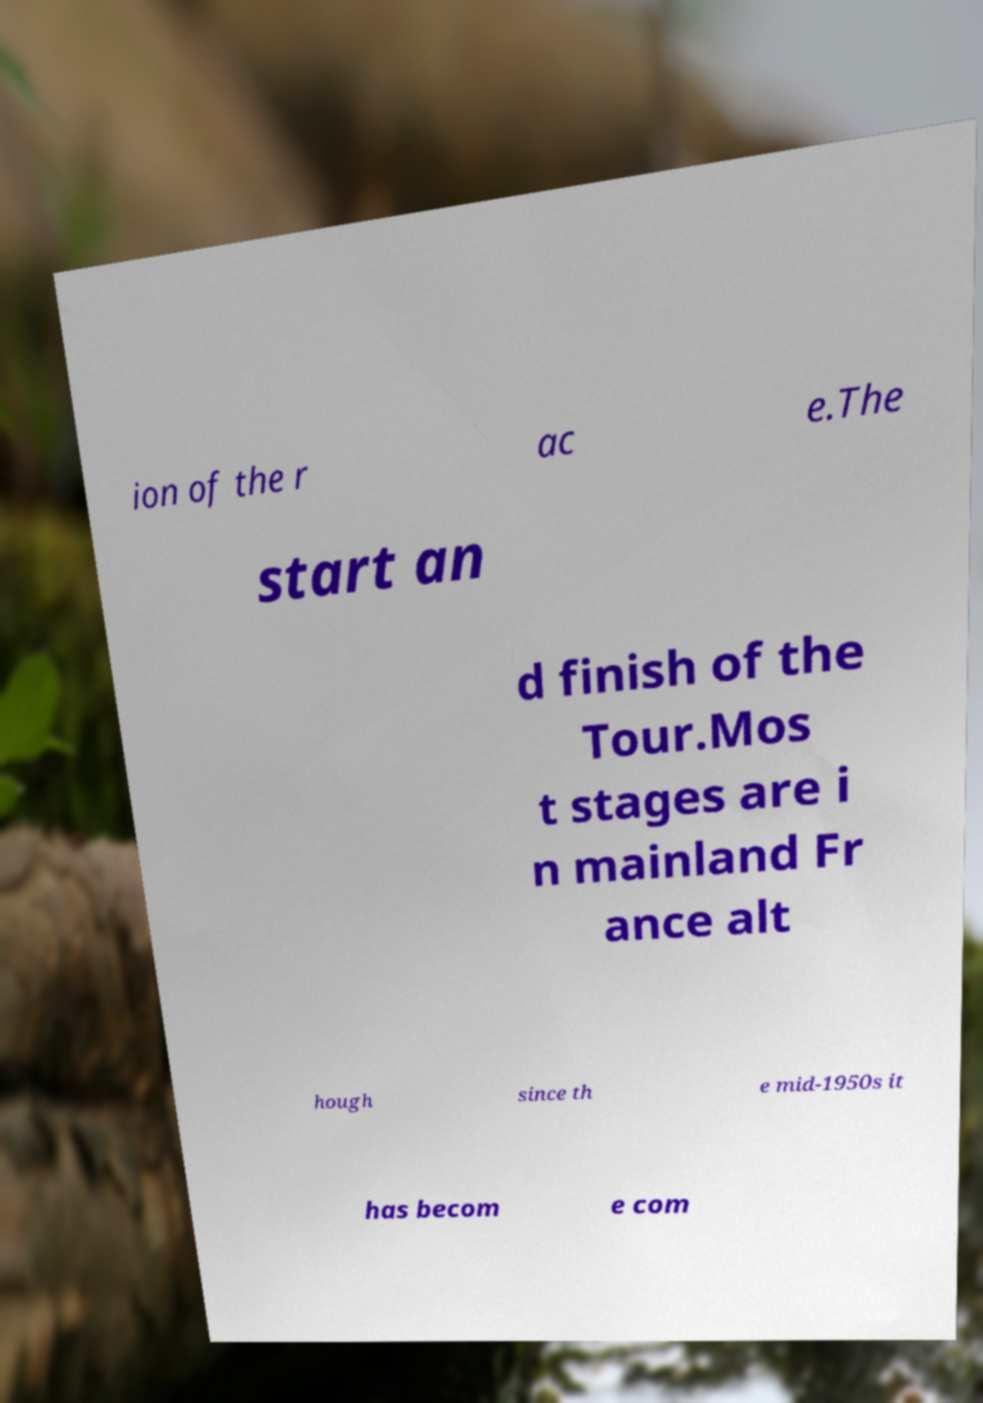For documentation purposes, I need the text within this image transcribed. Could you provide that? ion of the r ac e.The start an d finish of the Tour.Mos t stages are i n mainland Fr ance alt hough since th e mid-1950s it has becom e com 